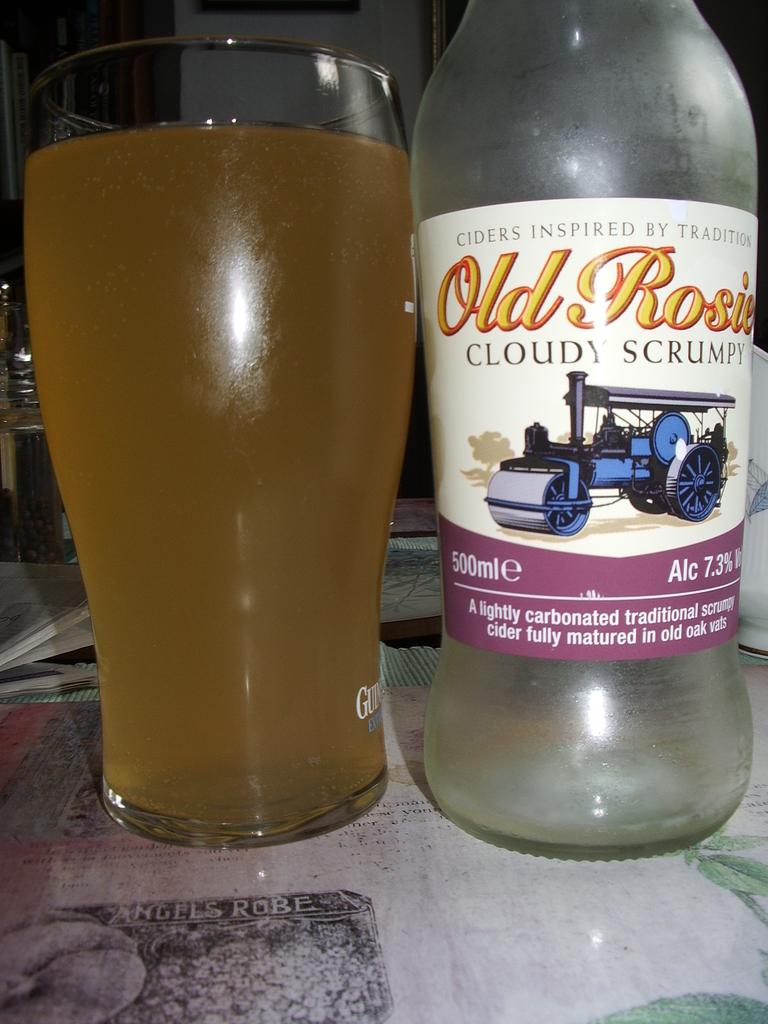How much alcohol by volume is in the beverage?
Your answer should be very brief. 7.3%. What is the brand of alcohol?
Offer a terse response. Old rosie. 